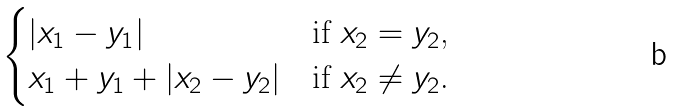Convert formula to latex. <formula><loc_0><loc_0><loc_500><loc_500>\begin{cases} | x _ { 1 } - y _ { 1 } | & \text {if $x_{2} =y_{2} $,} \\ x _ { 1 } + y _ { 1 } + | x _ { 2 } - y _ { 2 } | & \text {if $x_{2} \neq y_{2} $.} \end{cases}</formula> 